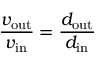Convert formula to latex. <formula><loc_0><loc_0><loc_500><loc_500>{ \frac { v _ { o u t } } { v _ { i n } } } = { \frac { d _ { o u t } } { d _ { i n } } }</formula> 